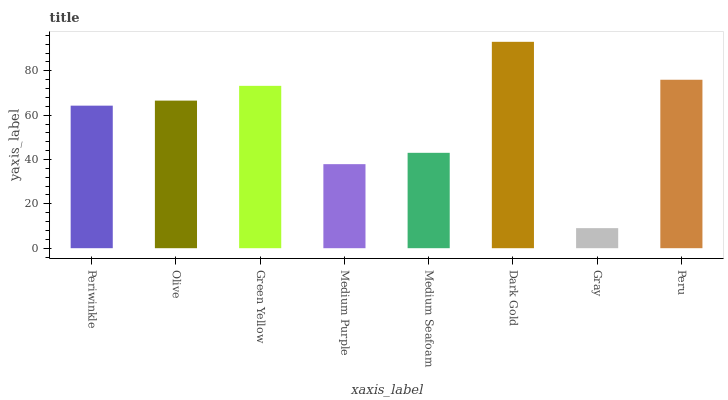Is Gray the minimum?
Answer yes or no. Yes. Is Dark Gold the maximum?
Answer yes or no. Yes. Is Olive the minimum?
Answer yes or no. No. Is Olive the maximum?
Answer yes or no. No. Is Olive greater than Periwinkle?
Answer yes or no. Yes. Is Periwinkle less than Olive?
Answer yes or no. Yes. Is Periwinkle greater than Olive?
Answer yes or no. No. Is Olive less than Periwinkle?
Answer yes or no. No. Is Olive the high median?
Answer yes or no. Yes. Is Periwinkle the low median?
Answer yes or no. Yes. Is Medium Purple the high median?
Answer yes or no. No. Is Dark Gold the low median?
Answer yes or no. No. 